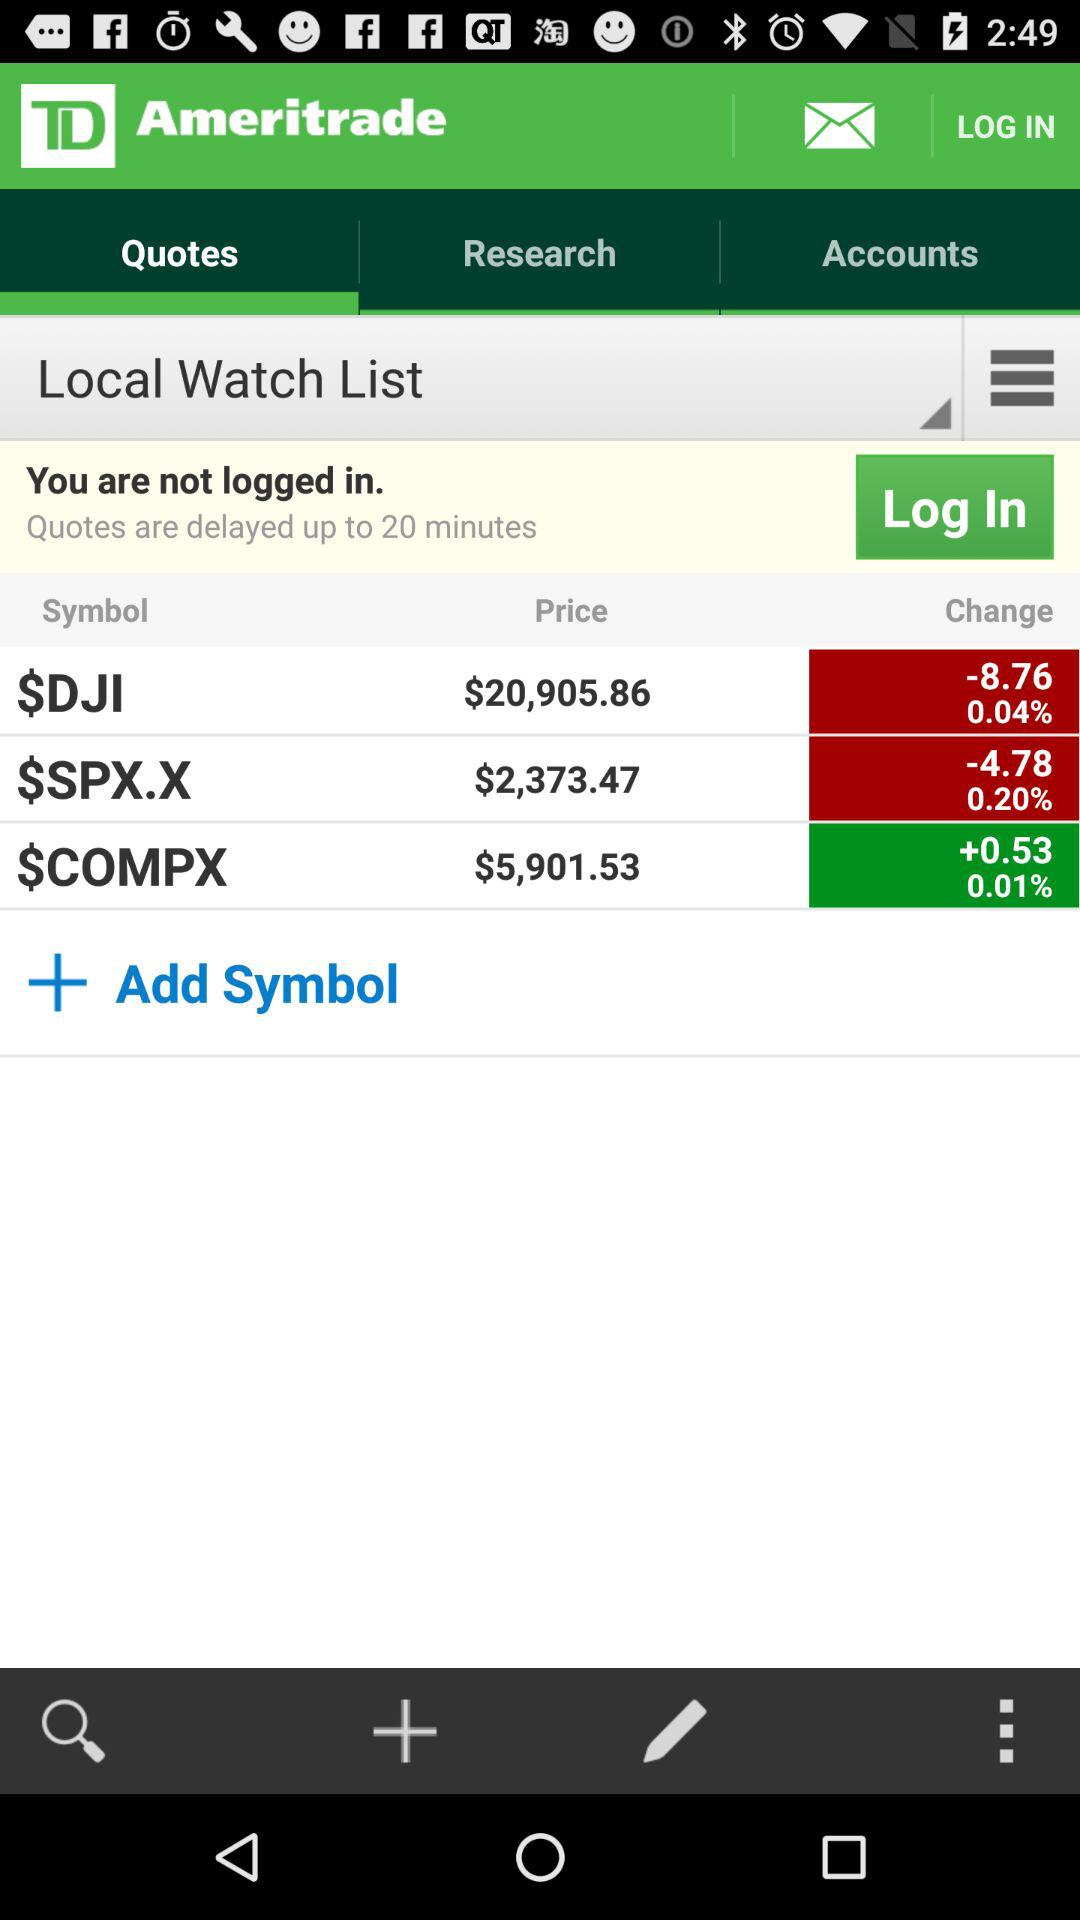How long are quotes delayed? Quotes are delayed up to 20 minutes. 